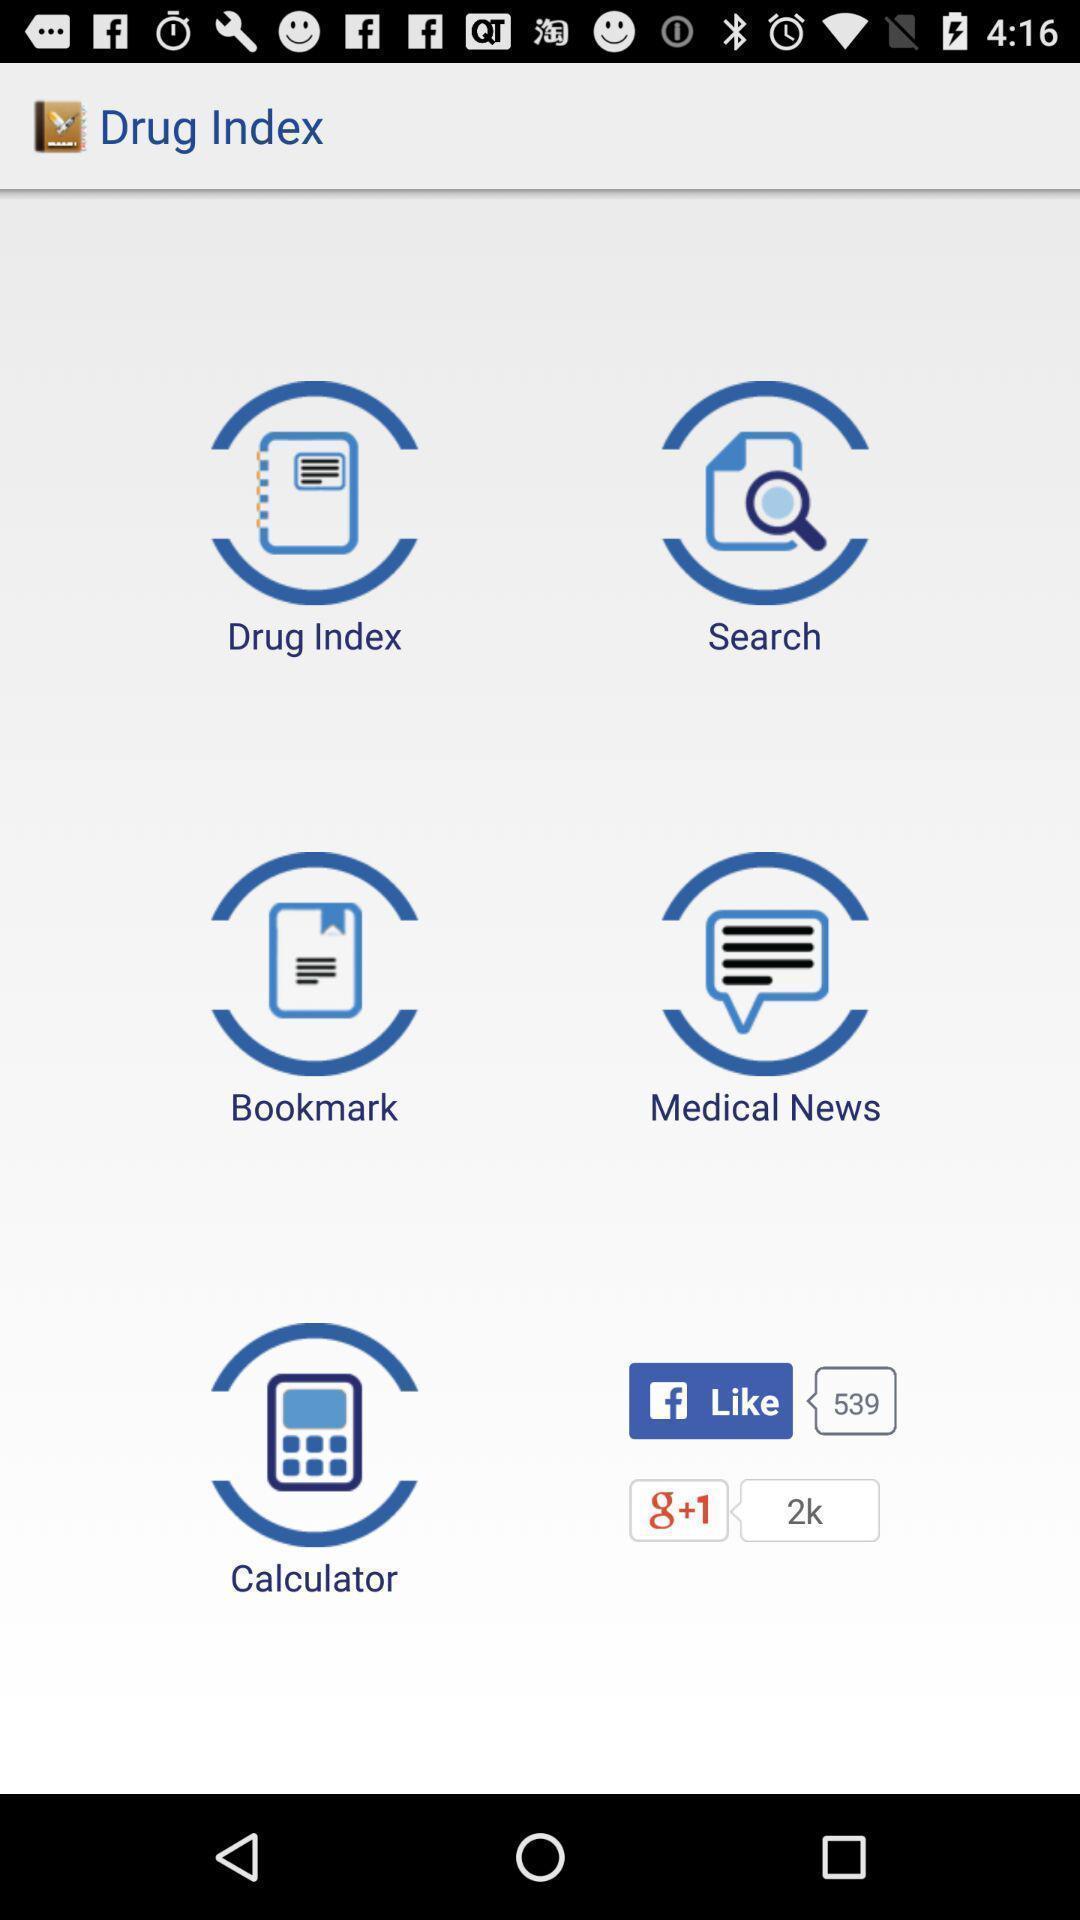Give me a summary of this screen capture. Page of a medical resource app with various other options. 